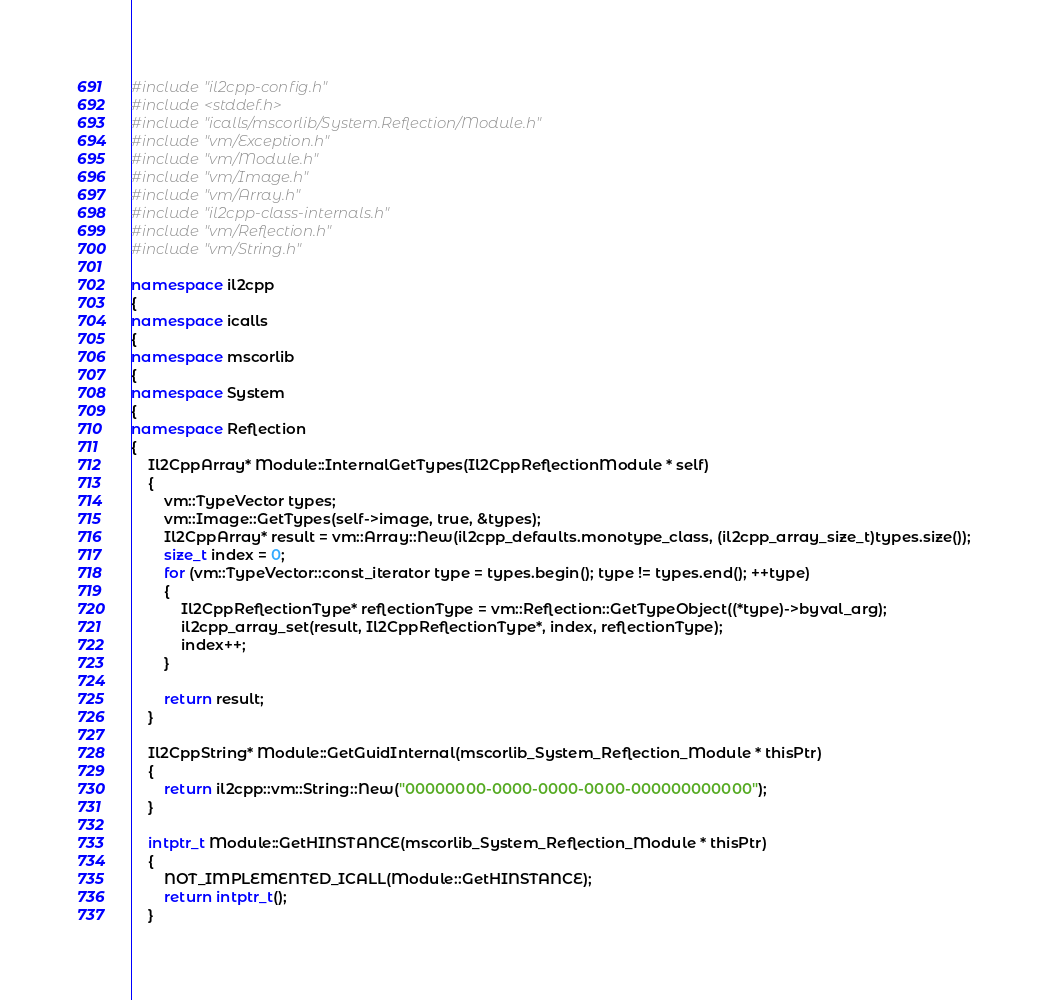<code> <loc_0><loc_0><loc_500><loc_500><_C++_>#include "il2cpp-config.h"
#include <stddef.h>
#include "icalls/mscorlib/System.Reflection/Module.h"
#include "vm/Exception.h"
#include "vm/Module.h"
#include "vm/Image.h"
#include "vm/Array.h"
#include "il2cpp-class-internals.h"
#include "vm/Reflection.h"
#include "vm/String.h"

namespace il2cpp
{
namespace icalls
{
namespace mscorlib
{
namespace System
{
namespace Reflection
{
    Il2CppArray* Module::InternalGetTypes(Il2CppReflectionModule * self)
    {
        vm::TypeVector types;
        vm::Image::GetTypes(self->image, true, &types);
        Il2CppArray* result = vm::Array::New(il2cpp_defaults.monotype_class, (il2cpp_array_size_t)types.size());
        size_t index = 0;
        for (vm::TypeVector::const_iterator type = types.begin(); type != types.end(); ++type)
        {
            Il2CppReflectionType* reflectionType = vm::Reflection::GetTypeObject((*type)->byval_arg);
            il2cpp_array_set(result, Il2CppReflectionType*, index, reflectionType);
            index++;
        }

        return result;
    }

    Il2CppString* Module::GetGuidInternal(mscorlib_System_Reflection_Module * thisPtr)
    {
        return il2cpp::vm::String::New("00000000-0000-0000-0000-000000000000");
    }

    intptr_t Module::GetHINSTANCE(mscorlib_System_Reflection_Module * thisPtr)
    {
        NOT_IMPLEMENTED_ICALL(Module::GetHINSTANCE);
        return intptr_t();
    }
</code> 